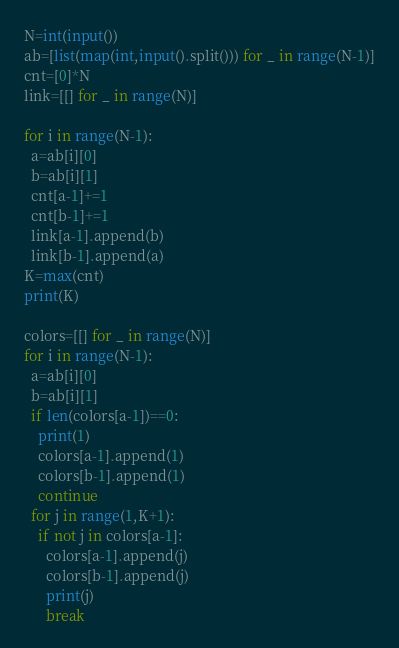<code> <loc_0><loc_0><loc_500><loc_500><_Python_>N=int(input())
ab=[list(map(int,input().split())) for _ in range(N-1)]
cnt=[0]*N
link=[[] for _ in range(N)]

for i in range(N-1):
  a=ab[i][0]
  b=ab[i][1]
  cnt[a-1]+=1
  cnt[b-1]+=1
  link[a-1].append(b)
  link[b-1].append(a)
K=max(cnt)
print(K)

colors=[[] for _ in range(N)]
for i in range(N-1):
  a=ab[i][0]
  b=ab[i][1]
  if len(colors[a-1])==0:
    print(1)
    colors[a-1].append(1)
    colors[b-1].append(1)
    continue
  for j in range(1,K+1):
    if not j in colors[a-1]:
      colors[a-1].append(j)
      colors[b-1].append(j)
      print(j)
      break</code> 